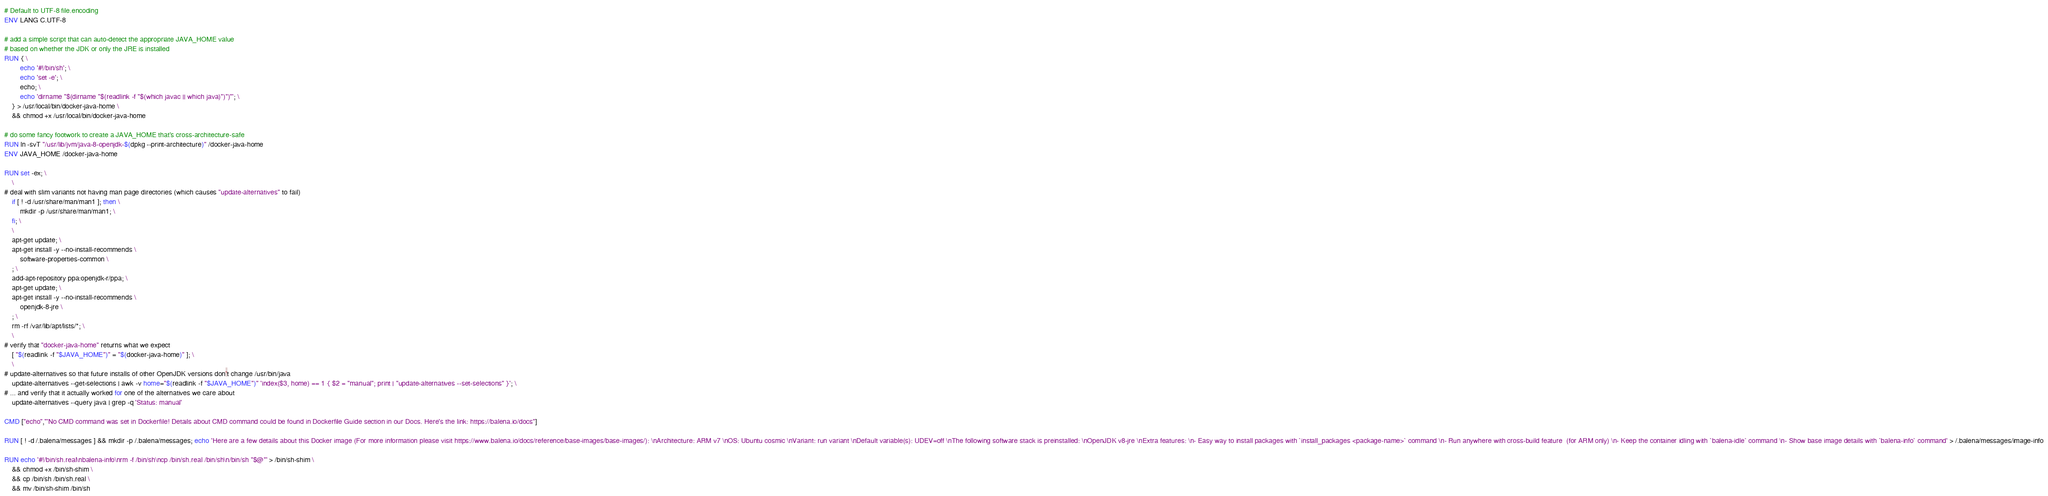Convert code to text. <code><loc_0><loc_0><loc_500><loc_500><_Dockerfile_># Default to UTF-8 file.encoding
ENV LANG C.UTF-8

# add a simple script that can auto-detect the appropriate JAVA_HOME value
# based on whether the JDK or only the JRE is installed
RUN { \
		echo '#!/bin/sh'; \
		echo 'set -e'; \
		echo; \
		echo 'dirname "$(dirname "$(readlink -f "$(which javac || which java)")")"'; \
	} > /usr/local/bin/docker-java-home \
	&& chmod +x /usr/local/bin/docker-java-home

# do some fancy footwork to create a JAVA_HOME that's cross-architecture-safe
RUN ln -svT "/usr/lib/jvm/java-8-openjdk-$(dpkg --print-architecture)" /docker-java-home
ENV JAVA_HOME /docker-java-home

RUN set -ex; \
	\
# deal with slim variants not having man page directories (which causes "update-alternatives" to fail)
	if [ ! -d /usr/share/man/man1 ]; then \
		mkdir -p /usr/share/man/man1; \
	fi; \
	\
	apt-get update; \
	apt-get install -y --no-install-recommends \
		software-properties-common \
	; \
	add-apt-repository ppa:openjdk-r/ppa; \
	apt-get update; \
	apt-get install -y --no-install-recommends \
		openjdk-8-jre \
	; \
	rm -rf /var/lib/apt/lists/*; \
	\
# verify that "docker-java-home" returns what we expect
	[ "$(readlink -f "$JAVA_HOME")" = "$(docker-java-home)" ]; \
	\
# update-alternatives so that future installs of other OpenJDK versions don't change /usr/bin/java
	update-alternatives --get-selections | awk -v home="$(readlink -f "$JAVA_HOME")" 'index($3, home) == 1 { $2 = "manual"; print | "update-alternatives --set-selections" }'; \
# ... and verify that it actually worked for one of the alternatives we care about
	update-alternatives --query java | grep -q 'Status: manual'

CMD ["echo","'No CMD command was set in Dockerfile! Details about CMD command could be found in Dockerfile Guide section in our Docs. Here's the link: https://balena.io/docs"]

RUN [ ! -d /.balena/messages ] && mkdir -p /.balena/messages; echo 'Here are a few details about this Docker image (For more information please visit https://www.balena.io/docs/reference/base-images/base-images/): \nArchitecture: ARM v7 \nOS: Ubuntu cosmic \nVariant: run variant \nDefault variable(s): UDEV=off \nThe following software stack is preinstalled: \nOpenJDK v8-jre \nExtra features: \n- Easy way to install packages with `install_packages <package-name>` command \n- Run anywhere with cross-build feature  (for ARM only) \n- Keep the container idling with `balena-idle` command \n- Show base image details with `balena-info` command' > /.balena/messages/image-info

RUN echo '#!/bin/sh.real\nbalena-info\nrm -f /bin/sh\ncp /bin/sh.real /bin/sh\n/bin/sh "$@"' > /bin/sh-shim \
	&& chmod +x /bin/sh-shim \
	&& cp /bin/sh /bin/sh.real \
	&& mv /bin/sh-shim /bin/sh</code> 